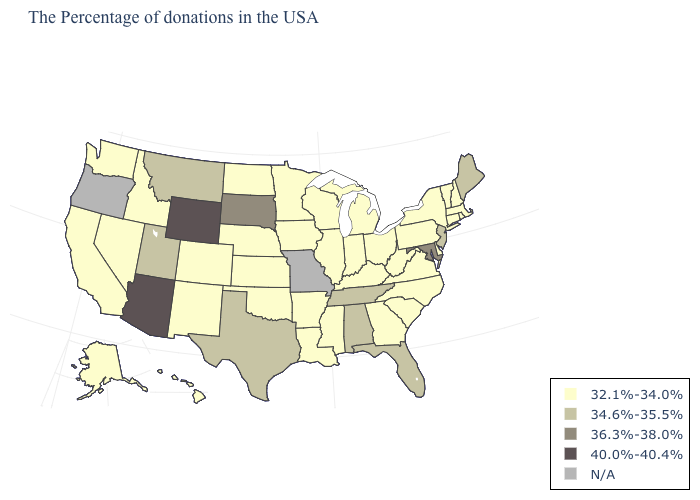What is the lowest value in the USA?
Be succinct. 32.1%-34.0%. What is the value of Washington?
Be succinct. 32.1%-34.0%. What is the value of West Virginia?
Answer briefly. 32.1%-34.0%. Does Maryland have the lowest value in the USA?
Short answer required. No. What is the highest value in the MidWest ?
Be succinct. 36.3%-38.0%. Name the states that have a value in the range 34.6%-35.5%?
Quick response, please. Maine, New Jersey, Florida, Alabama, Tennessee, Texas, Utah, Montana. Name the states that have a value in the range 36.3%-38.0%?
Answer briefly. Maryland, South Dakota. Among the states that border Illinois , which have the highest value?
Write a very short answer. Kentucky, Indiana, Wisconsin, Iowa. What is the value of North Dakota?
Answer briefly. 32.1%-34.0%. Which states have the lowest value in the MidWest?
Keep it brief. Ohio, Michigan, Indiana, Wisconsin, Illinois, Minnesota, Iowa, Kansas, Nebraska, North Dakota. Among the states that border Nevada , which have the lowest value?
Keep it brief. Idaho, California. Name the states that have a value in the range 36.3%-38.0%?
Answer briefly. Maryland, South Dakota. Among the states that border Nebraska , does Colorado have the highest value?
Short answer required. No. What is the highest value in states that border Mississippi?
Short answer required. 34.6%-35.5%. Does Alabama have the highest value in the South?
Be succinct. No. 